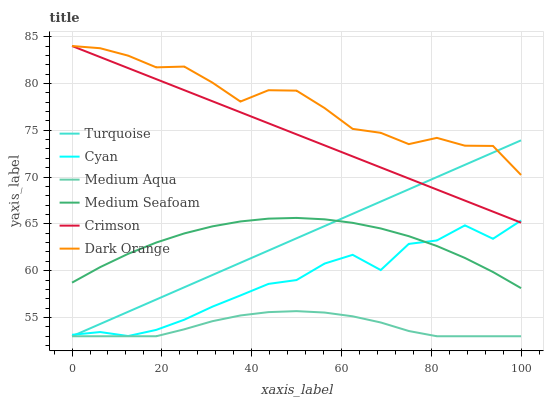Does Medium Aqua have the minimum area under the curve?
Answer yes or no. Yes. Does Dark Orange have the maximum area under the curve?
Answer yes or no. Yes. Does Turquoise have the minimum area under the curve?
Answer yes or no. No. Does Turquoise have the maximum area under the curve?
Answer yes or no. No. Is Turquoise the smoothest?
Answer yes or no. Yes. Is Cyan the roughest?
Answer yes or no. Yes. Is Medium Aqua the smoothest?
Answer yes or no. No. Is Medium Aqua the roughest?
Answer yes or no. No. Does Turquoise have the lowest value?
Answer yes or no. Yes. Does Crimson have the lowest value?
Answer yes or no. No. Does Crimson have the highest value?
Answer yes or no. Yes. Does Turquoise have the highest value?
Answer yes or no. No. Is Medium Aqua less than Dark Orange?
Answer yes or no. Yes. Is Dark Orange greater than Cyan?
Answer yes or no. Yes. Does Cyan intersect Medium Seafoam?
Answer yes or no. Yes. Is Cyan less than Medium Seafoam?
Answer yes or no. No. Is Cyan greater than Medium Seafoam?
Answer yes or no. No. Does Medium Aqua intersect Dark Orange?
Answer yes or no. No. 